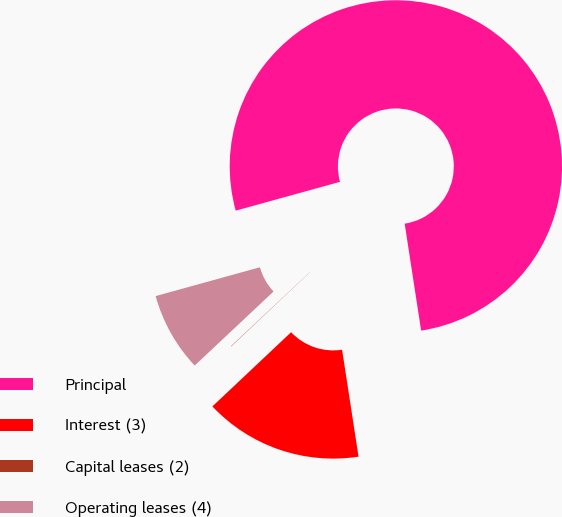Convert chart. <chart><loc_0><loc_0><loc_500><loc_500><pie_chart><fcel>Principal<fcel>Interest (3)<fcel>Capital leases (2)<fcel>Operating leases (4)<nl><fcel>76.87%<fcel>15.4%<fcel>0.03%<fcel>7.71%<nl></chart> 